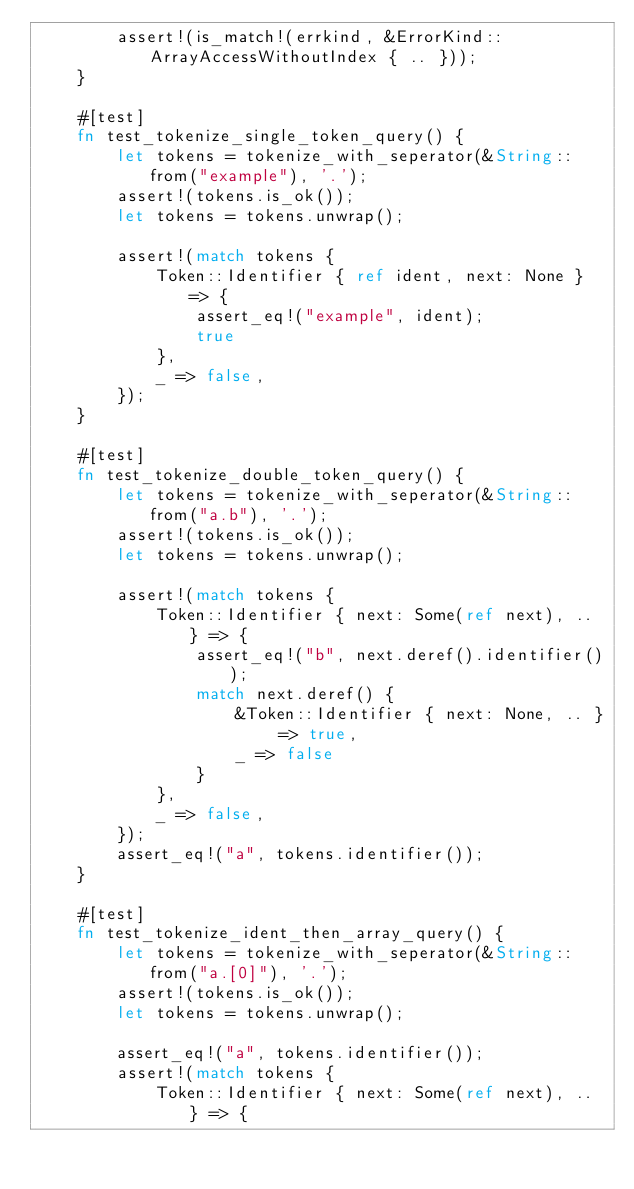Convert code to text. <code><loc_0><loc_0><loc_500><loc_500><_Rust_>        assert!(is_match!(errkind, &ErrorKind::ArrayAccessWithoutIndex { .. }));
    }

    #[test]
    fn test_tokenize_single_token_query() {
        let tokens = tokenize_with_seperator(&String::from("example"), '.');
        assert!(tokens.is_ok());
        let tokens = tokens.unwrap();

        assert!(match tokens {
            Token::Identifier { ref ident, next: None } => {
                assert_eq!("example", ident);
                true
            },
            _ => false,
        });
    }

    #[test]
    fn test_tokenize_double_token_query() {
        let tokens = tokenize_with_seperator(&String::from("a.b"), '.');
        assert!(tokens.is_ok());
        let tokens = tokens.unwrap();

        assert!(match tokens {
            Token::Identifier { next: Some(ref next), .. } => { 
                assert_eq!("b", next.deref().identifier());
                match next.deref() {
                    &Token::Identifier { next: None, .. } => true,
                    _ => false
                }
            },
            _ => false,
        });
        assert_eq!("a", tokens.identifier());
    }

    #[test]
    fn test_tokenize_ident_then_array_query() {
        let tokens = tokenize_with_seperator(&String::from("a.[0]"), '.');
        assert!(tokens.is_ok());
        let tokens = tokens.unwrap();

        assert_eq!("a", tokens.identifier());
        assert!(match tokens {
            Token::Identifier { next: Some(ref next), .. } => {</code> 